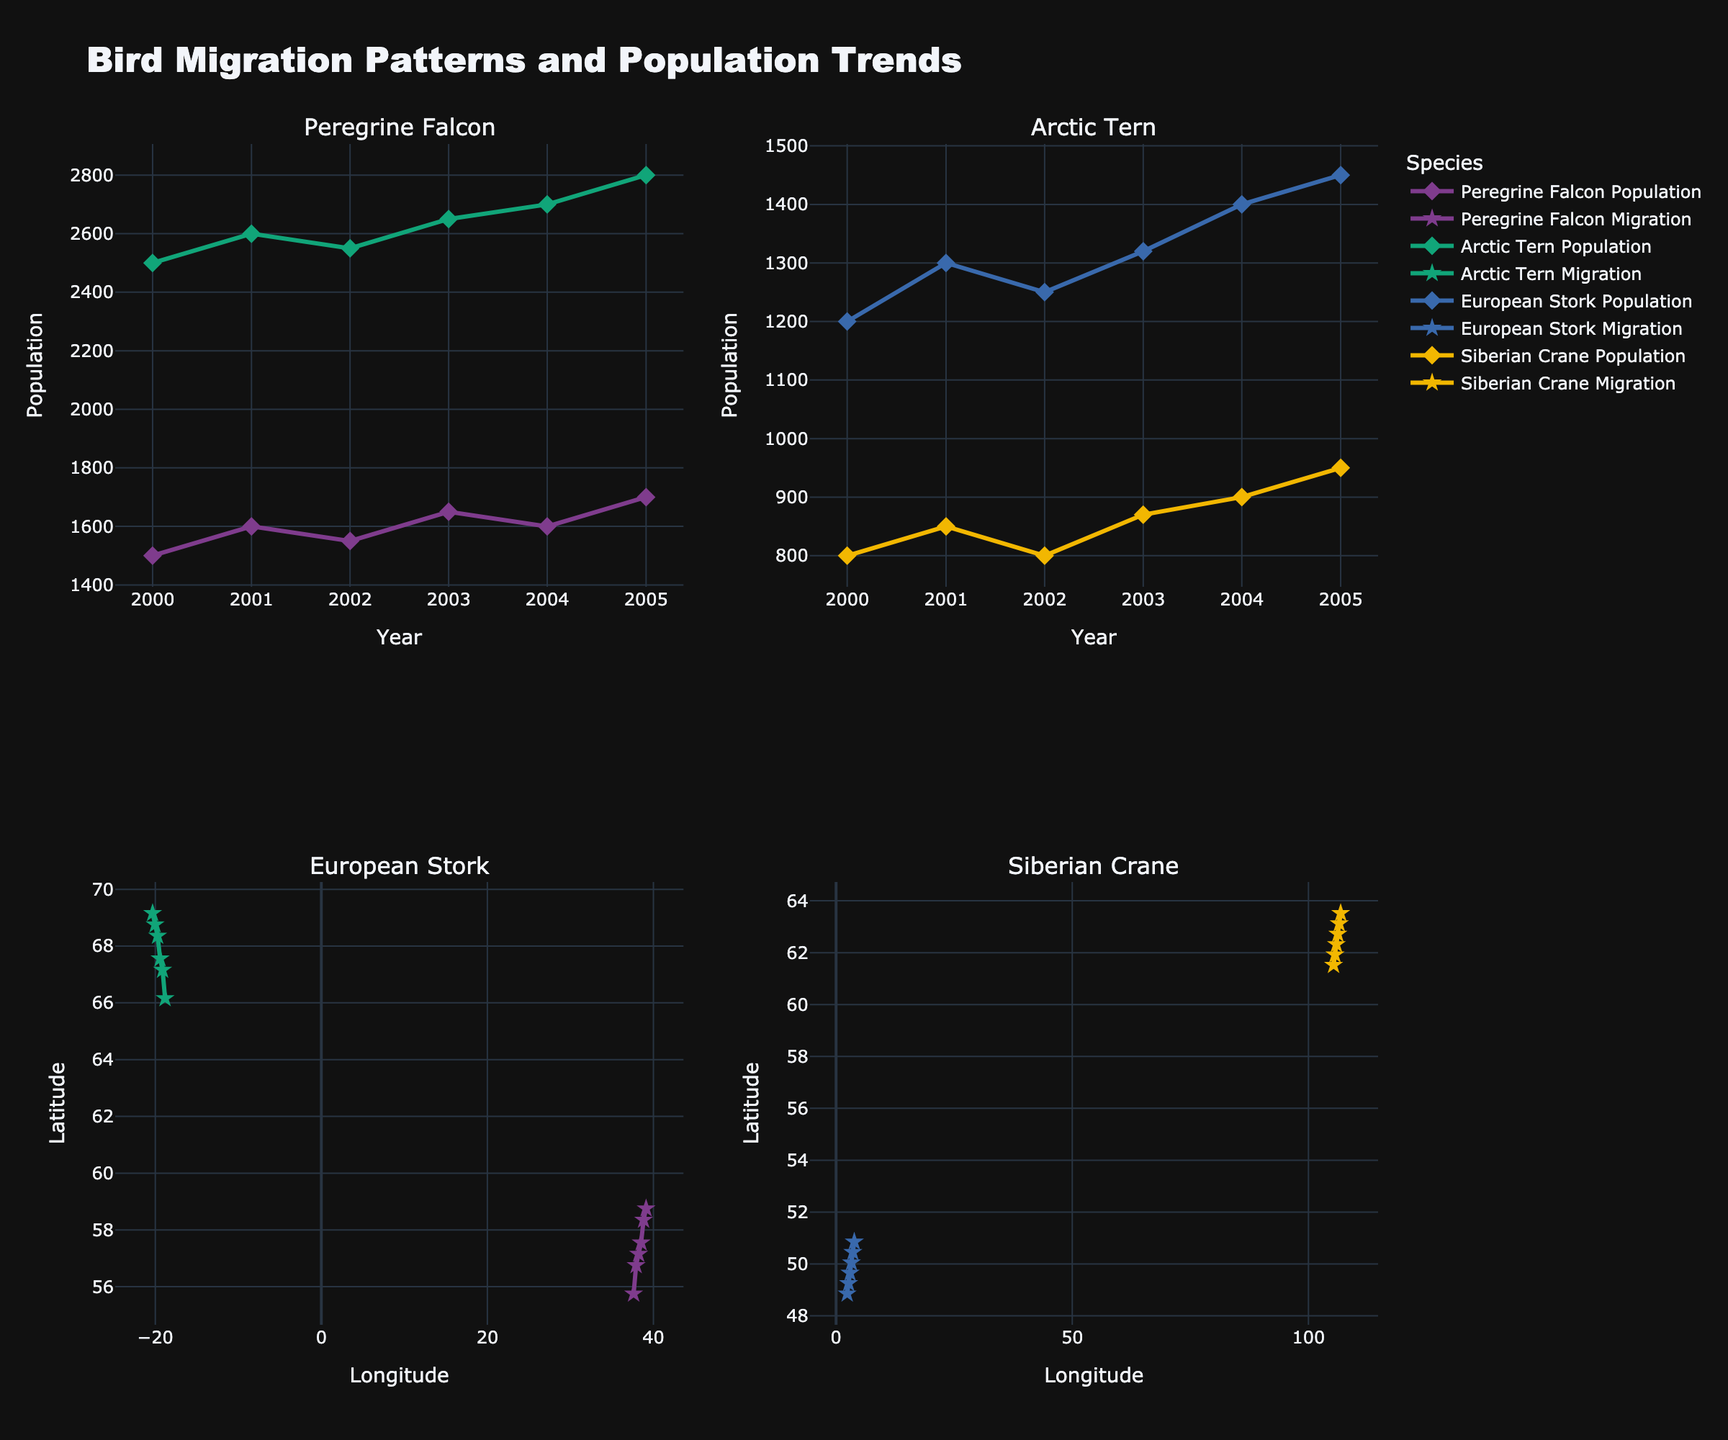How many species are displayed in the figure? The subplot titles indicate four species (Peregrine Falcon, Arctic Tern, European Stork, Siberian Crane). The data also shows records for these four species over the years.
Answer: 4 Which species has the highest recorded population? Checking the populations in each subplot, the Arctic Tern has a peak population of 2800 in the year 2005, which is the highest value among all species.
Answer: Arctic Tern What is the population trend of the Peregrine Falcon from 2000 to 2005? Observing the line plot for the Peregrine Falcon in the upper left subplot, we see an increasing trend from 1500 in 2000 to 1700 in 2005. The population slightly fluctuates but generally rises over the years.
Answer: Increasing What are the latitudinal changes in the migration path of the European Stork from 2000 to 2005? Reviewing the migration path in the lower left subplot, the latitude increases from 48.8566 in 2000 to 50.8566 in 2005, indicating a northward shift over the years.
Answer: Northward shift Which species shows the most significant change in migration longitude between 2000 and 2005? Examining all subplot migration paths, Siberian Crane displays a notable shift from 105.3188 in 2000 to 106.8188 in 2005, a substantial longitudinal change compared to other species.
Answer: Siberian Crane How does the population variance of the Arctic Tern compare to that of the European Stork over the same period? Calculating the range for each species: Arctic Tern’s population varies from 2500 to 2800 (a variance of 300) while European Stork’s population varies from 1200 to 1450 (a variance of 250). Thus, Arctic Tern has a higher population variance.
Answer: Arctic Tern What is the average population size of the Siberian Crane from 2000 to 2005? Summing up the populations (800 + 850 + 800 + 870 + 900 + 950) to get 5170, and dividing by the number of years (6), the average population size is approximately 861.67.
Answer: 861.67 Which species exhibits the smallest latitudinal change in their migration path over the years? By checking the range of latitudes for each species, Peregrine Falcon’s latitude changes from 55.7558 to 63.5240, which is the smallest compared to other species.
Answer: Peregrine Falcon 